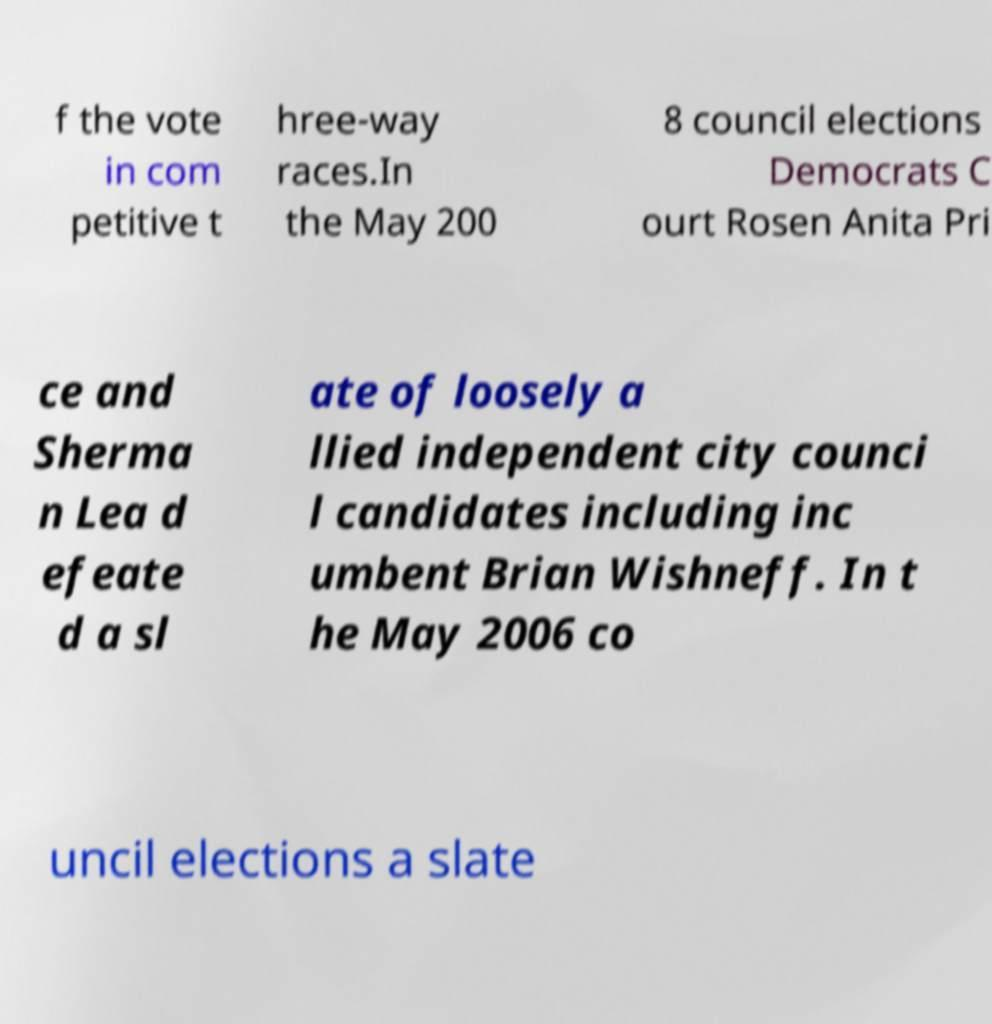Can you accurately transcribe the text from the provided image for me? f the vote in com petitive t hree-way races.In the May 200 8 council elections Democrats C ourt Rosen Anita Pri ce and Sherma n Lea d efeate d a sl ate of loosely a llied independent city counci l candidates including inc umbent Brian Wishneff. In t he May 2006 co uncil elections a slate 